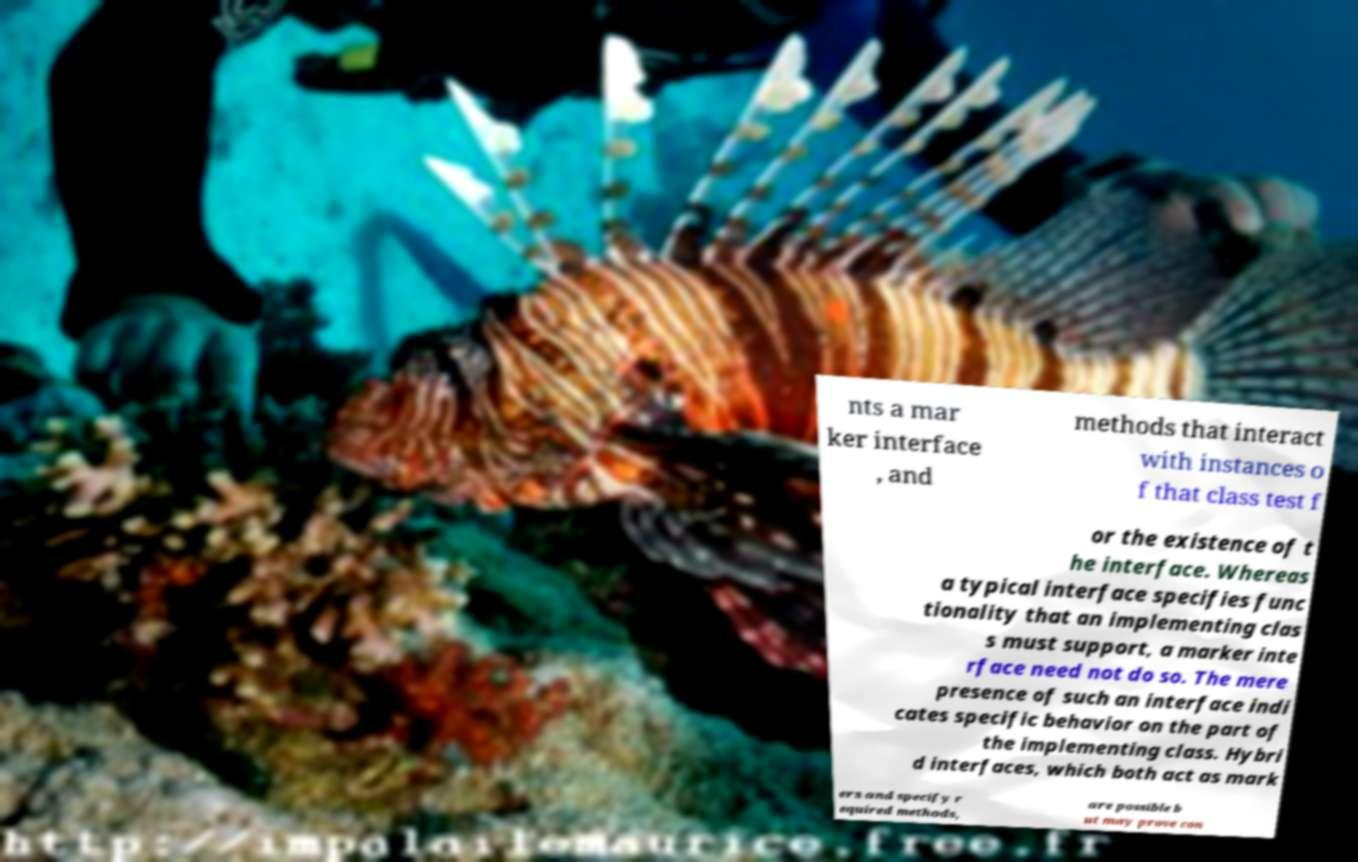What messages or text are displayed in this image? I need them in a readable, typed format. nts a mar ker interface , and methods that interact with instances o f that class test f or the existence of t he interface. Whereas a typical interface specifies func tionality that an implementing clas s must support, a marker inte rface need not do so. The mere presence of such an interface indi cates specific behavior on the part of the implementing class. Hybri d interfaces, which both act as mark ers and specify r equired methods, are possible b ut may prove con 